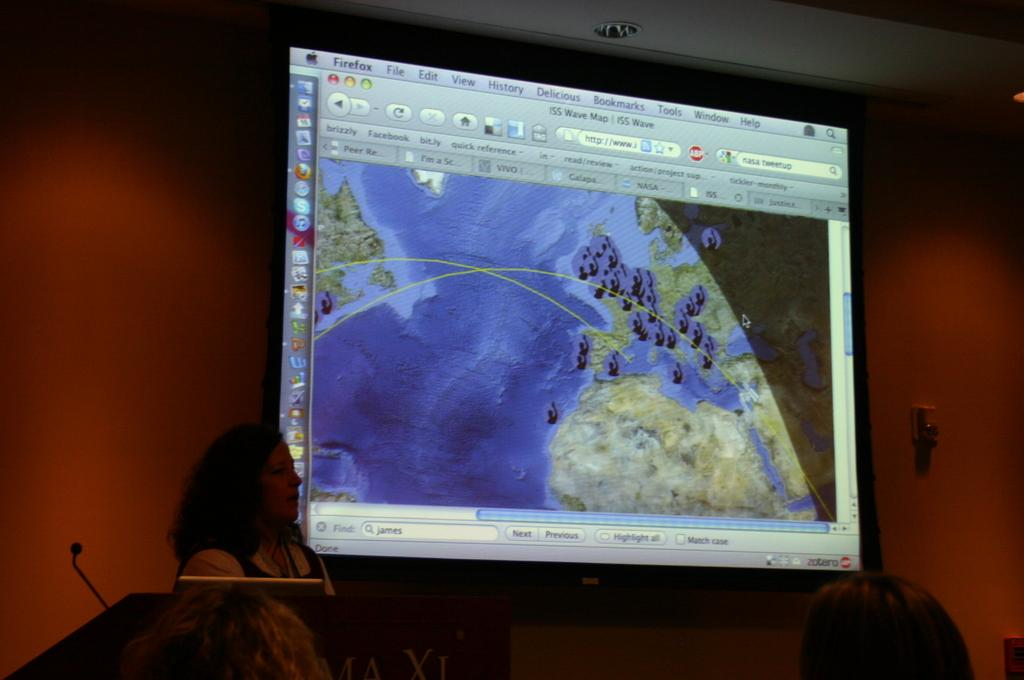How many people are in the foreground of the image? There are two persons standing in the foreground of the image. What objects are present in the foreground of the image? There is a table, a microphone (mike), and a screen in the foreground of the image. What can be seen in the background of the image? There is a wall in the background of the image. What type of location might the image be taken in? The image is likely taken in a hall. Can you see the quilt being used by the persons in the image? There is no quilt present in the image. How many times do the persons in the image cough during the event? The image does not provide any information about the persons coughing, so it cannot be determined. 